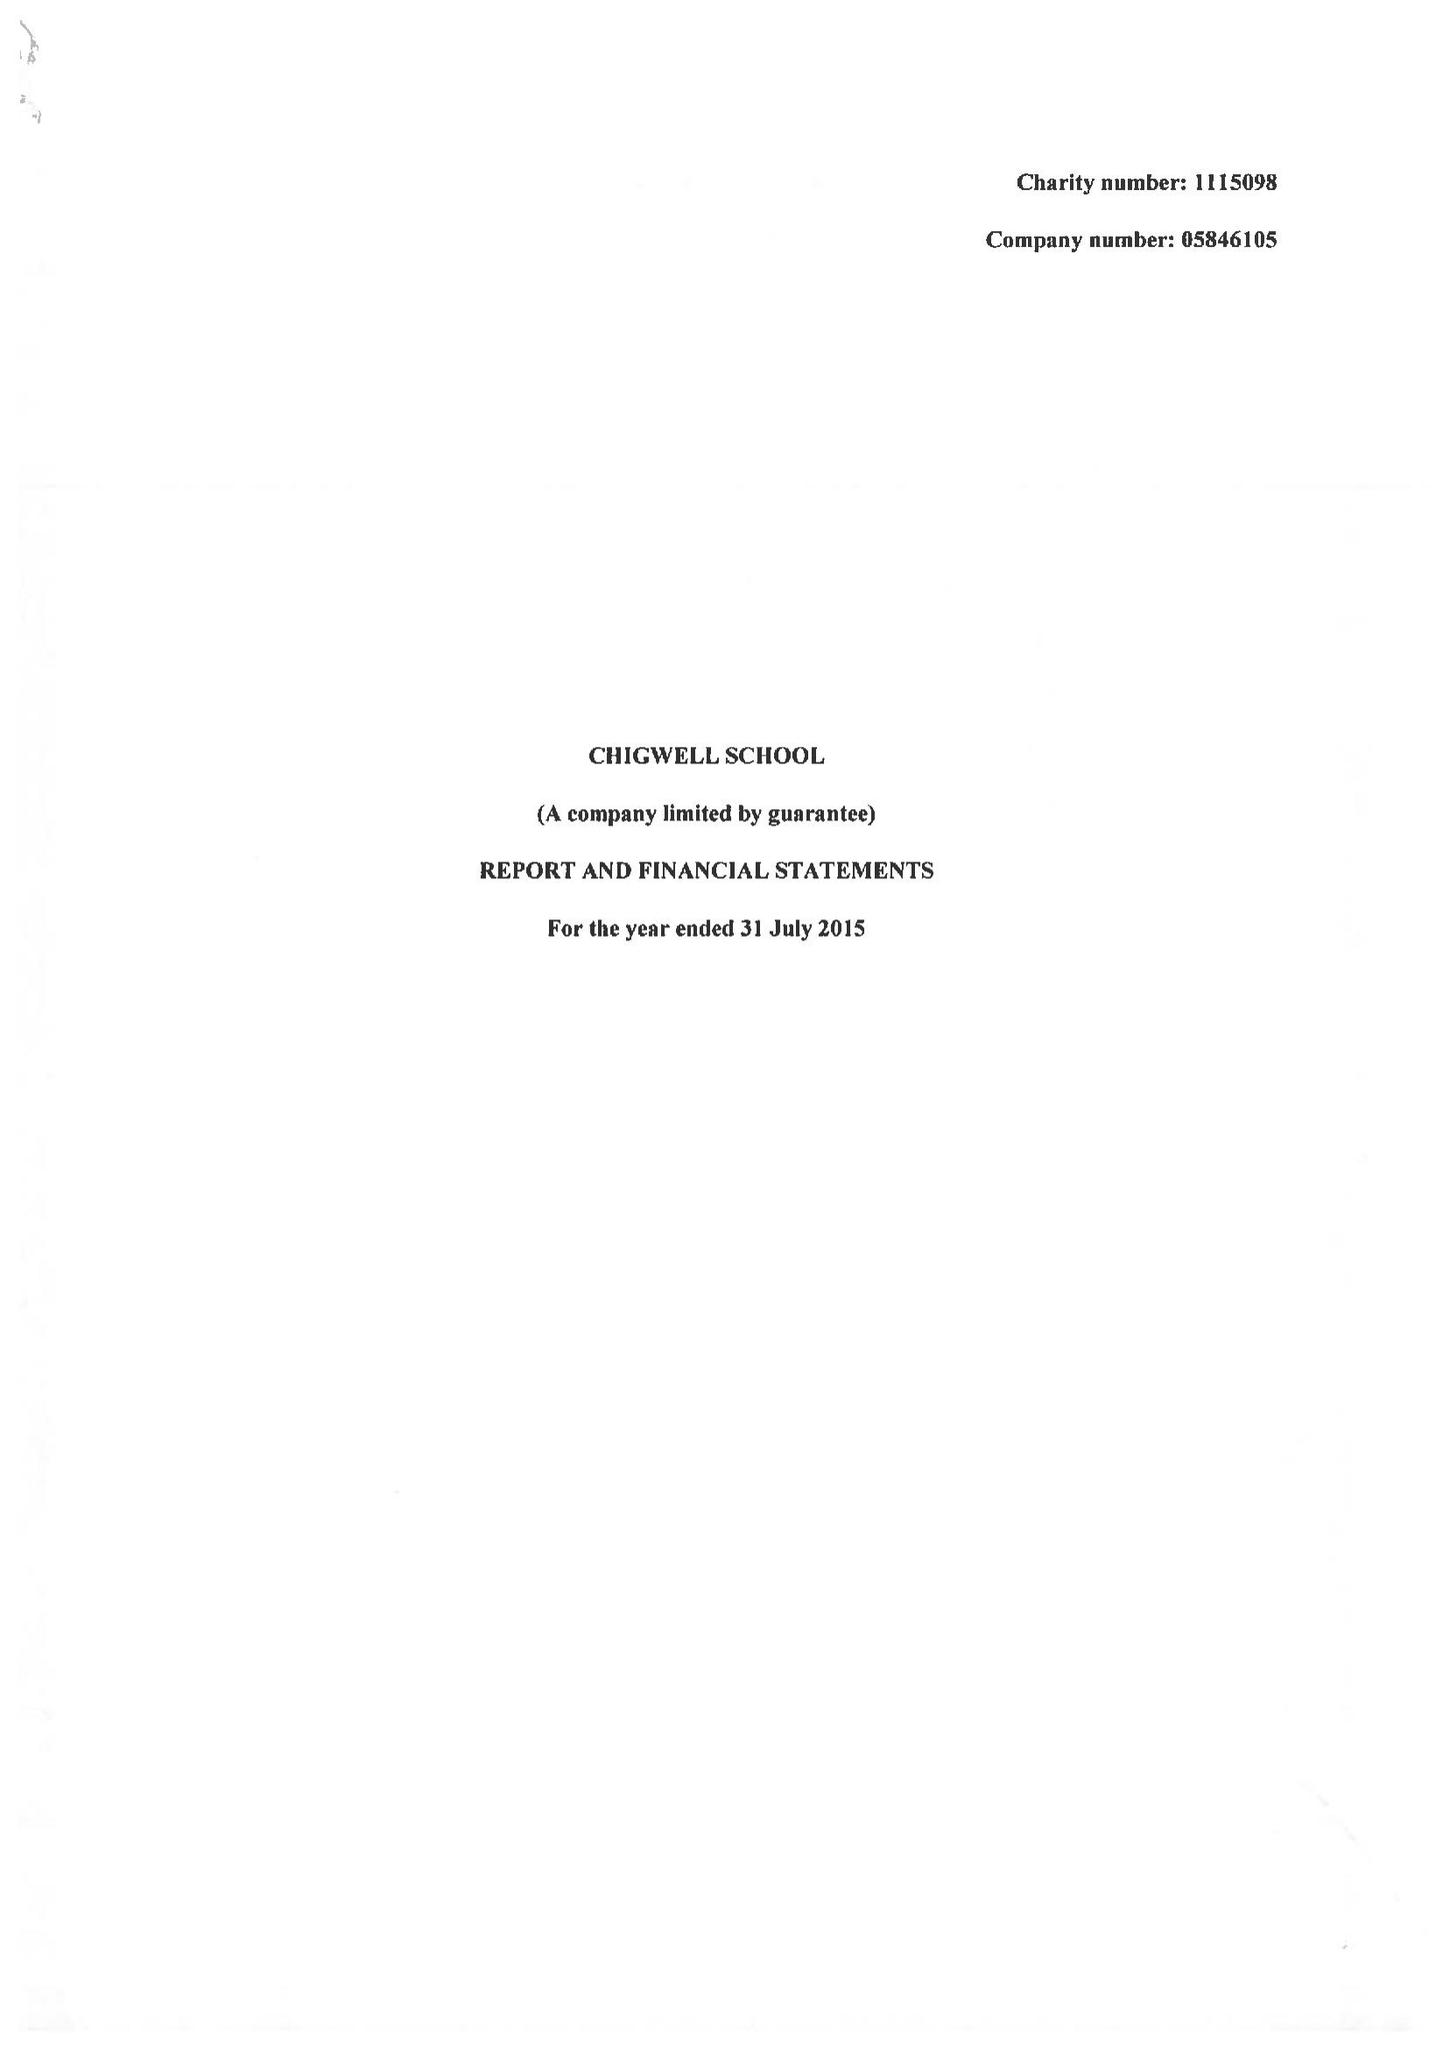What is the value for the charity_number?
Answer the question using a single word or phrase. 1115098 